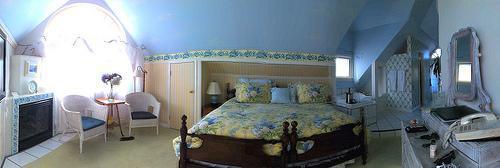How many chairs?
Give a very brief answer. 2. How many towels hanging on the back right wall?
Give a very brief answer. 2. 